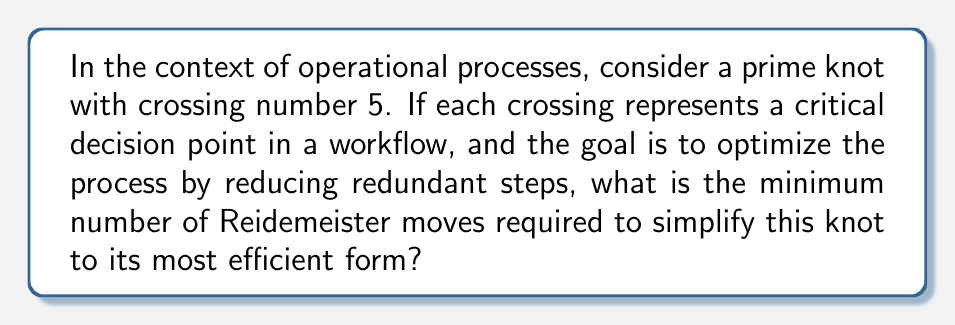Show me your answer to this math problem. Let's approach this step-by-step:

1) First, recall that prime knots are knots that cannot be decomposed into simpler knots. A knot with crossing number 5 is the simplest non-trivial prime knot.

2) In knot theory, Reidemeister moves are operations that can be performed on a knot diagram without changing the knot type. There are three types of Reidemeister moves:
   - Type I: Twisting or untwisting a strand
   - Type II: Moving one strand completely over or under another
   - Type III: Moving a strand over or under a crossing

3) The most efficient form of a knot is its minimal crossing number representation. For a prime knot with crossing number 5, this is already its most efficient form.

4) However, the question asks about simplifying the process, which we can interpret as reducing the number of crossings (decision points) without changing the fundamental structure (prime knot property).

5) For a prime knot, it's impossible to reduce the number of crossings below its crossing number without changing the knot type. Therefore, we cannot actually reduce the number of crossings.

6) The minimum number of Reidemeister moves required is thus 0, as any move would either:
   a) Not change the knot diagram at all, or
   b) Create a more complex representation that would then need to be reversed

7) In the context of operational processes, this suggests that the workflow represented by this prime knot is already in its most efficient form, with no redundant steps that can be eliminated without fundamentally altering the process.
Answer: 0 